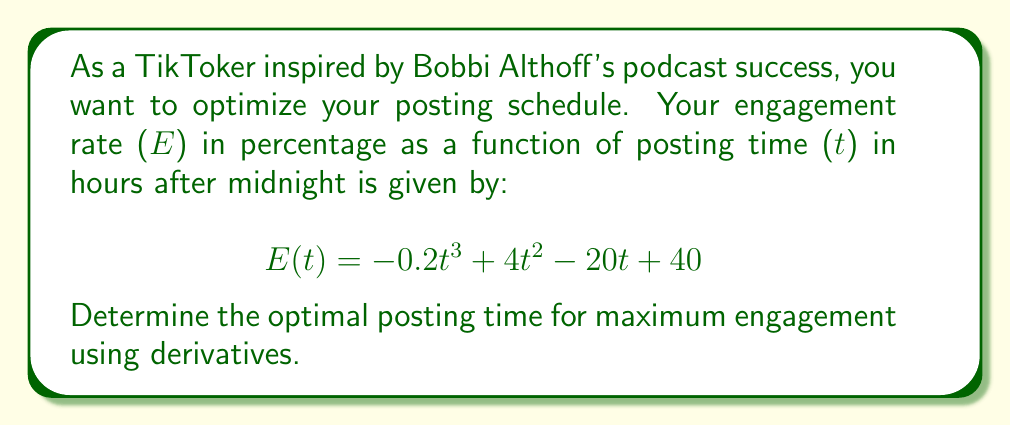Show me your answer to this math problem. 1) To find the optimal posting time for maximum engagement, we need to find the maximum of the function $E(t)$. This occurs where the derivative $E'(t) = 0$ and the second derivative $E''(t) < 0$.

2) First, let's find $E'(t)$:
   $$E'(t) = -0.6t^2 + 8t - 20$$

3) Set $E'(t) = 0$ and solve for t:
   $$-0.6t^2 + 8t - 20 = 0$$
   
   This is a quadratic equation. We can solve it using the quadratic formula:
   $$t = \frac{-b \pm \sqrt{b^2 - 4ac}}{2a}$$
   
   Where $a = -0.6$, $b = 8$, and $c = -20$

4) Substituting these values:
   $$t = \frac{-8 \pm \sqrt{64 - 4(-0.6)(-20)}}{2(-0.6)}$$
   $$= \frac{-8 \pm \sqrt{64 - 48}}{-1.2}$$
   $$= \frac{-8 \pm 4}{-1.2}$$

5) This gives us two solutions:
   $$t_1 = \frac{-8 + 4}{-1.2} = \frac{-4}{-1.2} = 3.33$$
   $$t_2 = \frac{-8 - 4}{-1.2} = \frac{-12}{-1.2} = 10$$

6) To determine which of these is the maximum, we need to check the second derivative:
   $$E''(t) = -1.2t + 8$$

7) Evaluating $E''(t)$ at both points:
   $$E''(3.33) = -1.2(3.33) + 8 = 4$$
   $$E''(10) = -1.2(10) + 8 = -4$$

8) Since $E''(10) < 0$, the maximum occurs at $t = 10$.

9) Converting 10 hours after midnight to standard time: 10:00 AM.
Answer: 10:00 AM 